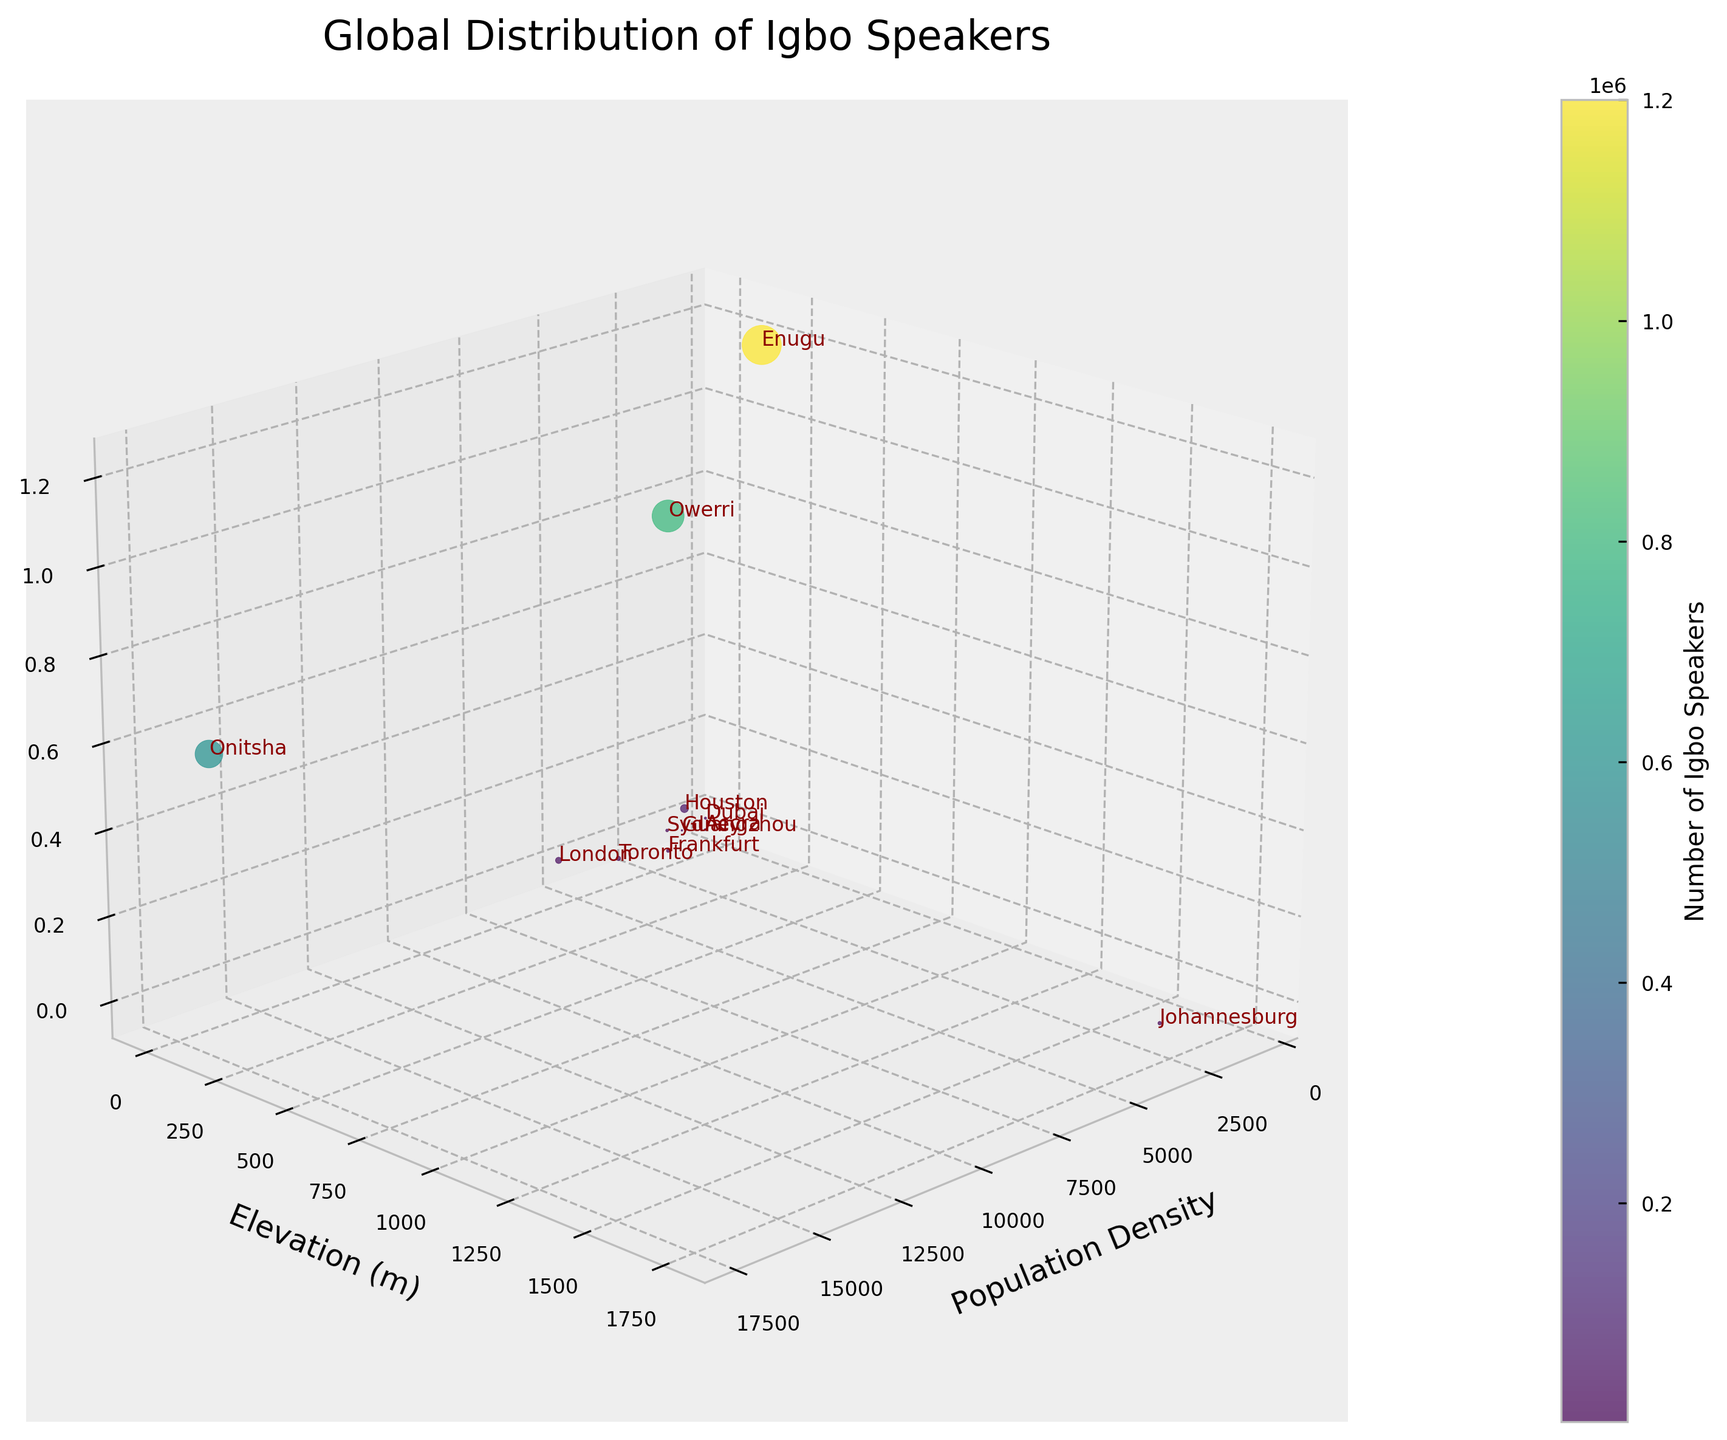what is the title of the 3D plot? The title is displayed at the top of the plot. It provides a brief description of what the plot represents.
Answer: Global Distribution of Igbo Speakers Which city has the highest number of Igbo speakers? From the vertical axis (Igbo Speakers) and labels next to the markers, we see that Enugu has the highest Igbo speaker population.
Answer: Enugu What is the population density of Onitsha? By finding Onitsha on the plot and looking at the corresponding position on the Population Density axis, we can determine the value.
Answer: 17215 Which city is depicted at the highest geographical elevation in the plot? By looking at the Elevation axis and finding the point furthest along this axis, we can see that Johannesburg is the highest.
Answer: Johannesburg Compare the number of Igbo speakers between London and Toronto. Which city has more? Locate London and Toronto on the plot. Compare their positions relative to the Igbo Speakers axis. London has 30,000 while Toronto has 15,000.
Answer: London How does the number of Igbo speakers in Sydney compare to Johannesburg? Locate the data points for Sydney and Johannesburg and compare their vertical positions. Sydney has 6,000 while Johannesburg has 10,000 Igbo speakers.
Answer: Johannesburg has more What is the average population density of Nigerian cities in the plot? Identify the Nigerian cities (Enugu, Owerri, Onitsha) and sum their population densities: 967 + 2617 + 17215 = 20899. Divide by the number of cities: 20899 / 3.
Answer: 6966.33 What color scale is used to represent the number of Igbo speakers? Observe the color of the markers and refer to the color bar on the side of the plot that is labeled to represent the number of Igbo speakers using a certain color gradient. The hues range from lower to higher speaker numbers.
Answer: viridis Do cities with higher population density generally have more Igbo speakers? Observe the general trend in the plot; cities like Onitsha with high population densities tend to have higher Igbo speaker numbers, while cities with lower densities like Dubai have fewer. This indicates a positive correlation.
Answer: Yes, generally Which city has the lowest elevation among the top 3 cities with the highest number of Igbo speakers? Among the top 3 cities (Enugu, Owerri, Onitsha), compare their elevations: Enugu (223 m), Owerri (71 m), Onitsha (106 m). Owerri has the lowest elevation.
Answer: Owerri 